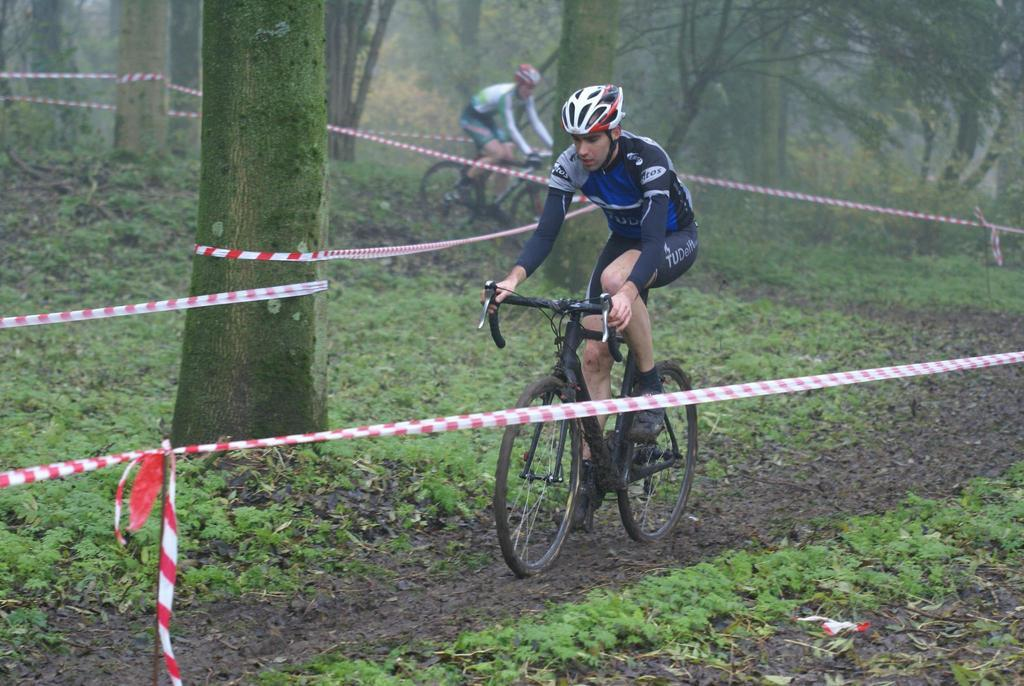How many people are in the image? There are two persons in the image. What are the persons doing in the image? The persons are riding bicycles. Can you describe the object around them? There is an object in red and white colors around them. What can be seen in the background of the image? There are trees in the background of the image. How many ducks are swimming in the water near the persons in the image? There are no ducks present in the image. What type of quiver is being used by the persons in the image? There is no quiver visible in the image; the persons are riding bicycles. 